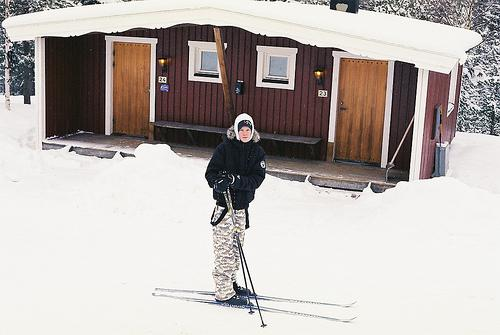Question: how many doors are on the building?
Choices:
A. Three.
B. Four.
C. Two.
D. Five.
Answer with the letter. Answer: C Question: who is standing in front of the building?
Choices:
A. Man on snowboard.
B. Woman on skis.
C. Woman on snowboard.
D. Man on skis.
Answer with the letter. Answer: B Question: what season is it?
Choices:
A. Spring.
B. Summer.
C. Winter.
D. Fall.
Answer with the letter. Answer: C Question: what side of the woman is the ski poles?
Choices:
A. Right side.
B. Left side.
C. In front of her.
D. Behind her.
Answer with the letter. Answer: A Question: where is a shovel?
Choices:
A. In the shed.
B. Back of garage.
C. On the ground next to walkway.
D. Front of right door.
Answer with the letter. Answer: D Question: what shape are the windows?
Choices:
A. Rectangle.
B. Octagon.
C. Squares.
D. Round.
Answer with the letter. Answer: C Question: how many people are outside?
Choices:
A. One.
B. Two.
C. Five.
D. Seven.
Answer with the letter. Answer: A 